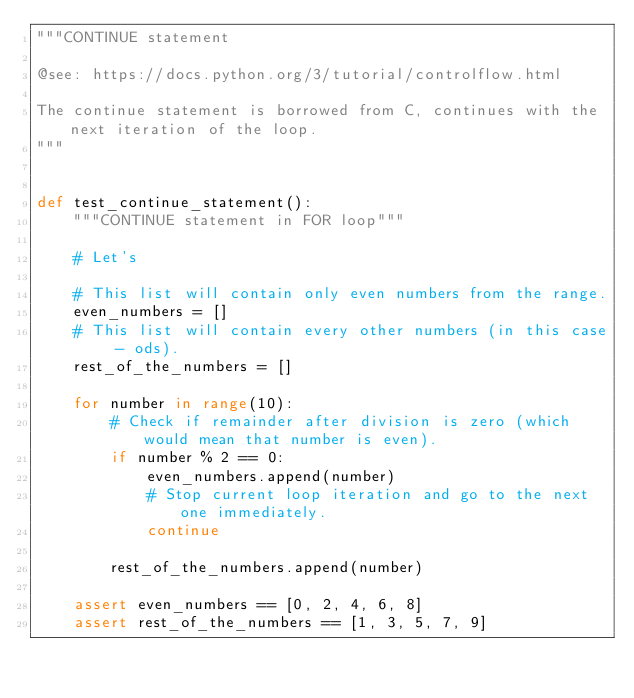<code> <loc_0><loc_0><loc_500><loc_500><_Python_>"""CONTINUE statement

@see: https://docs.python.org/3/tutorial/controlflow.html

The continue statement is borrowed from C, continues with the next iteration of the loop.
"""


def test_continue_statement():
    """CONTINUE statement in FOR loop"""

    # Let's

    # This list will contain only even numbers from the range.
    even_numbers = []
    # This list will contain every other numbers (in this case - ods).
    rest_of_the_numbers = []

    for number in range(10):
        # Check if remainder after division is zero (which would mean that number is even).
        if number % 2 == 0:
            even_numbers.append(number)
            # Stop current loop iteration and go to the next one immediately.
            continue

        rest_of_the_numbers.append(number)

    assert even_numbers == [0, 2, 4, 6, 8]
    assert rest_of_the_numbers == [1, 3, 5, 7, 9]
</code> 